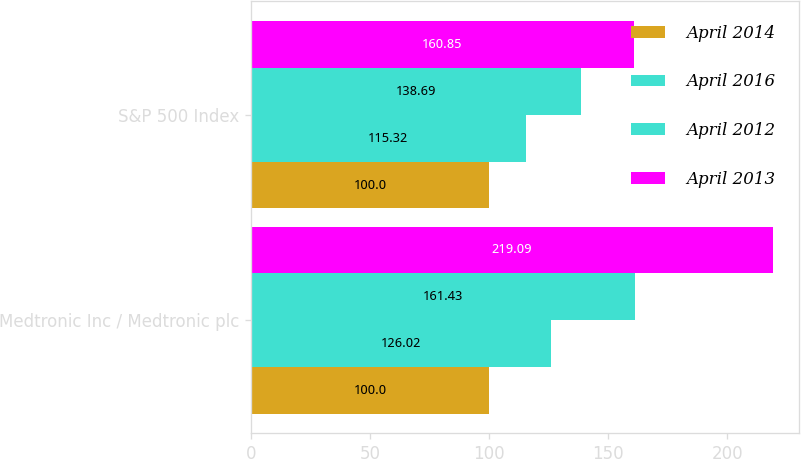<chart> <loc_0><loc_0><loc_500><loc_500><stacked_bar_chart><ecel><fcel>Medtronic Inc / Medtronic plc<fcel>S&P 500 Index<nl><fcel>April 2014<fcel>100<fcel>100<nl><fcel>April 2016<fcel>126.02<fcel>115.32<nl><fcel>April 2012<fcel>161.43<fcel>138.69<nl><fcel>April 2013<fcel>219.09<fcel>160.85<nl></chart> 